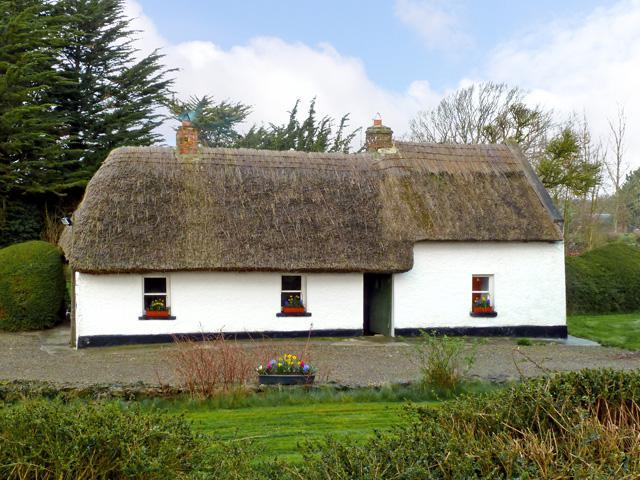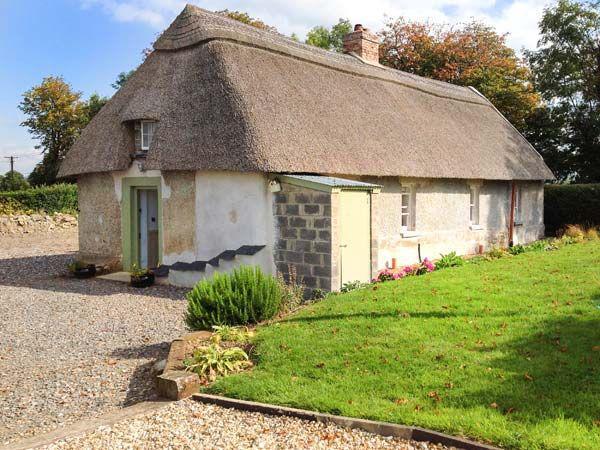The first image is the image on the left, the second image is the image on the right. Examine the images to the left and right. Is the description "The house in the left image has one chimney." accurate? Answer yes or no. No. The first image is the image on the left, the second image is the image on the right. For the images shown, is this caption "There are no fewer than 2 chimneys in the image on the left." true? Answer yes or no. Yes. 